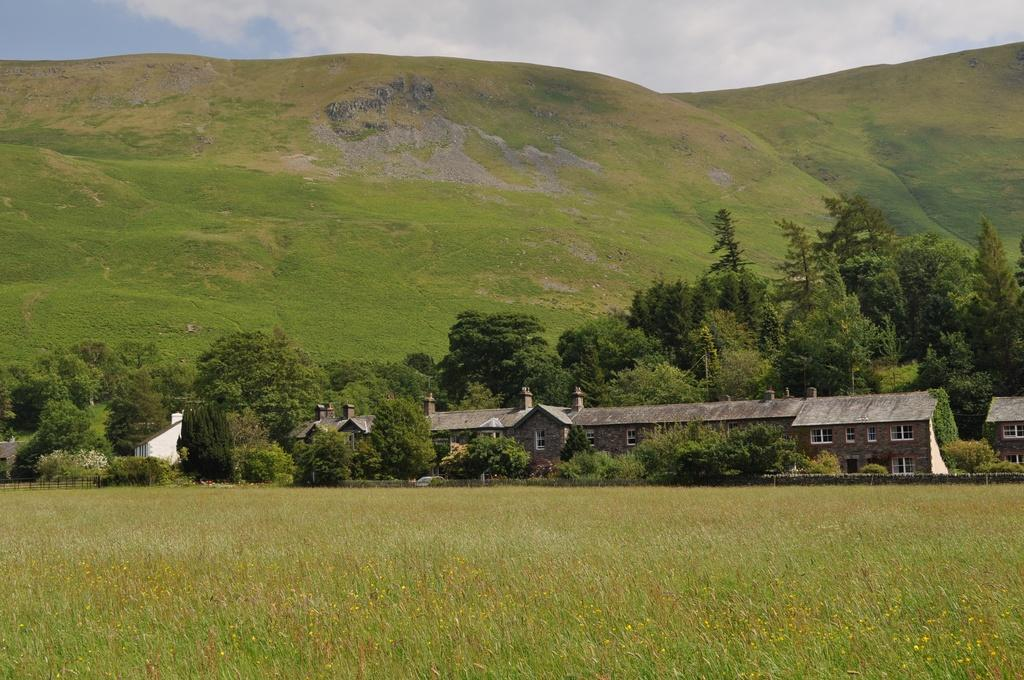What type of vegetation is present in the foreground of the image? There is grass in the foreground of the image. What structure is located in the middle of the image? There is a building in the middle of the image. What else can be seen in the middle of the image besides the building? There are trees and grass in the middle of the image. What is visible at the top of the image? The sky is visible at the top of the image, and there are clouds visible in the sky. Where is the knife located in the image? There is no knife present in the image. What type of writing instrument is used by the quill in the image? There is no quill present in the image. 